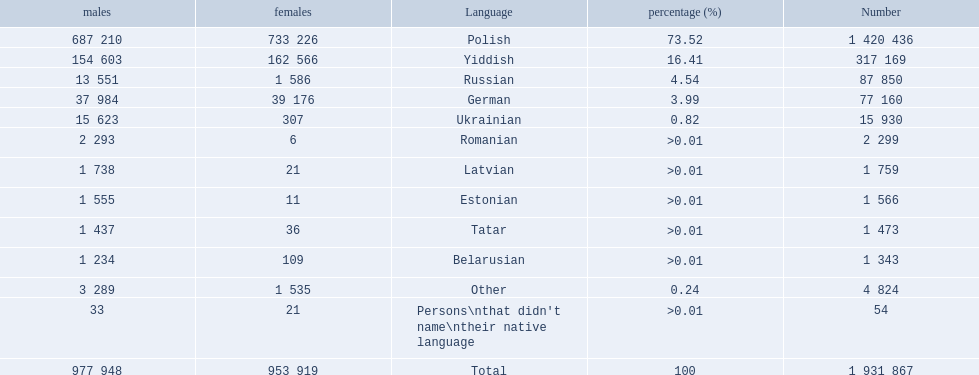What languages are spoken in the warsaw governorate? Polish, Yiddish, Russian, German, Ukrainian, Romanian, Latvian, Estonian, Tatar, Belarusian. Which are the top five languages? Polish, Yiddish, Russian, German, Ukrainian. Of those which is the 2nd most frequently spoken? Yiddish. 